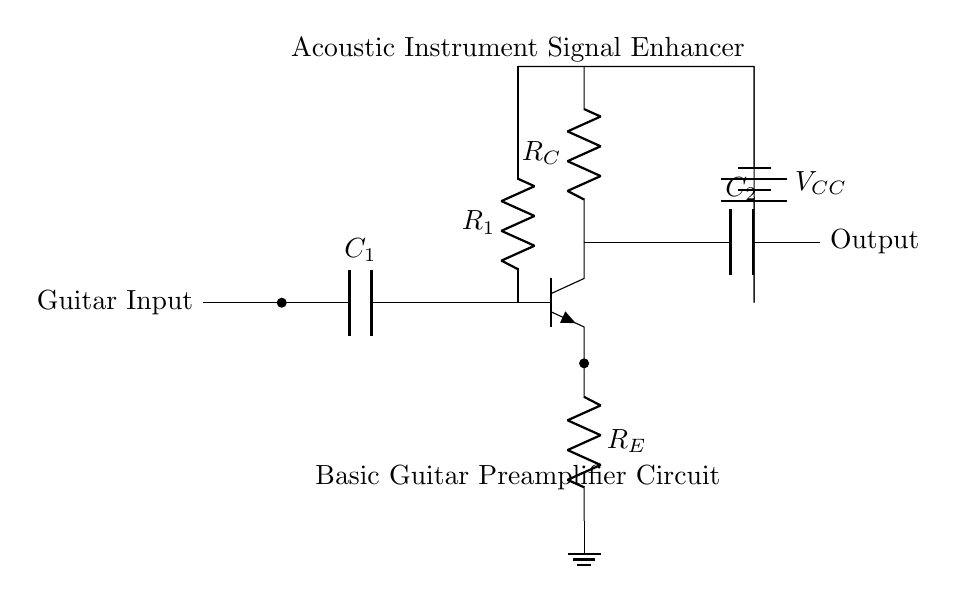What is the total number of capacitors in the circuit? The circuit contains two capacitors, denoted as C1 and C2. They are labeled next to their respective symbols in the diagram.
Answer: 2 What is the function of resistor R1 in this circuit? Resistor R1 is used to provide bias to the transistor, allowing it to operate in the correct region for amplification. This is critical for the functioning of the preamplifier.
Answer: Biasing What is the type of transistor used in the circuit? The circuit uses an NPN transistor, as indicated by the npn symbol next to the designated component.
Answer: NPN What is the role of capacitor C2 in the circuit? Capacitor C2 serves as a coupling capacitor, allowing the amplified AC signal to pass to the output while blocking any DC component. This is essential for preventing DC from affecting downstream components.
Answer: Coupling What voltage is provided to the circuit from the power supply? The power supply voltage is labeled as VCC, though the exact numerical value is not specified in the diagram. It is important for powering the transistor and other components.
Answer: VCC What is the purpose of resistor R_E? Resistor R_E is used to provide stability and negative feedback, which helps improve the linearity and performance of the amplifier circuit. This feedback ensures that the gain remains more consistent across different signal levels.
Answer: Stability What type of input signal is the preamplifier designed to work with? The preamplifier is designed to enhance acoustic instrument signals, indicating that it is tailored for low-level audio signals commonly produced by acoustic instruments like guitars.
Answer: Acoustic instrument signals 